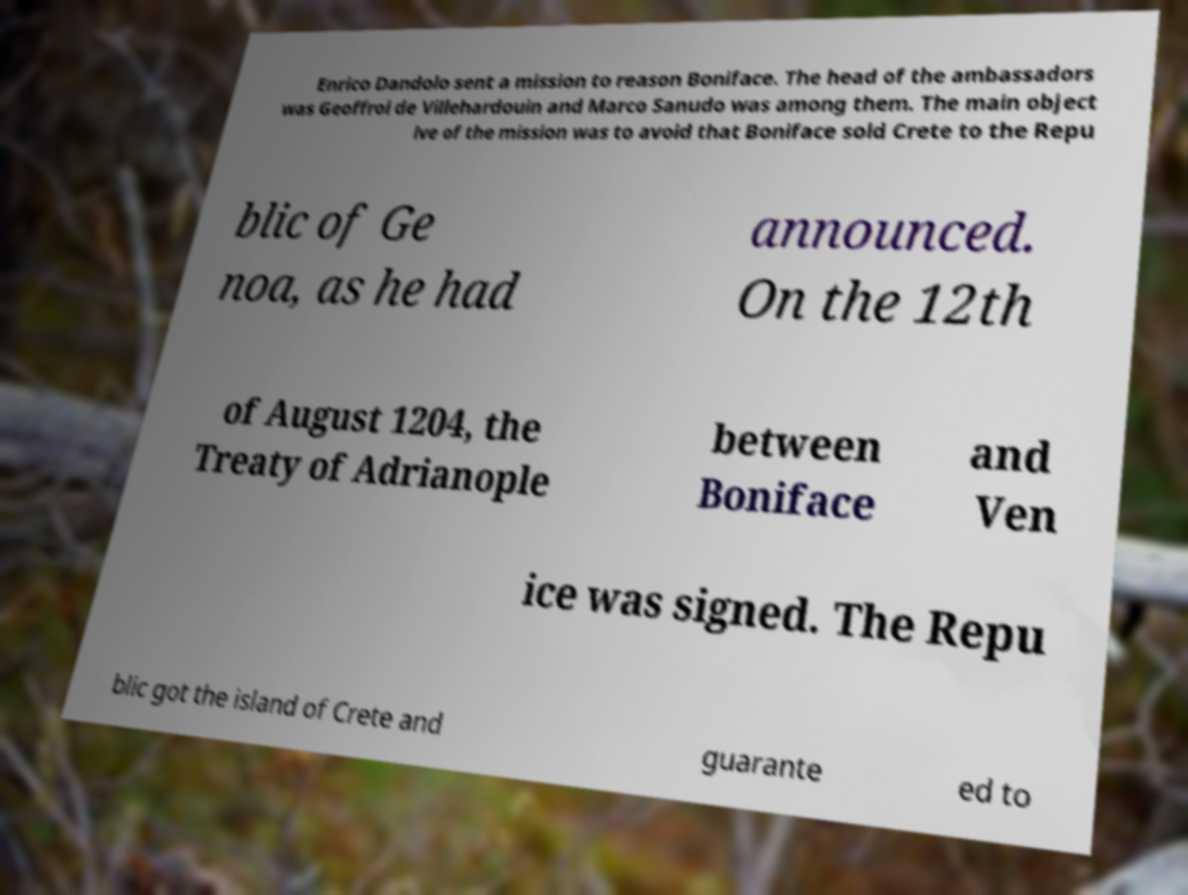Could you assist in decoding the text presented in this image and type it out clearly? Enrico Dandolo sent a mission to reason Boniface. The head of the ambassadors was Geoffroi de Villehardouin and Marco Sanudo was among them. The main object ive of the mission was to avoid that Boniface sold Crete to the Repu blic of Ge noa, as he had announced. On the 12th of August 1204, the Treaty of Adrianople between Boniface and Ven ice was signed. The Repu blic got the island of Crete and guarante ed to 